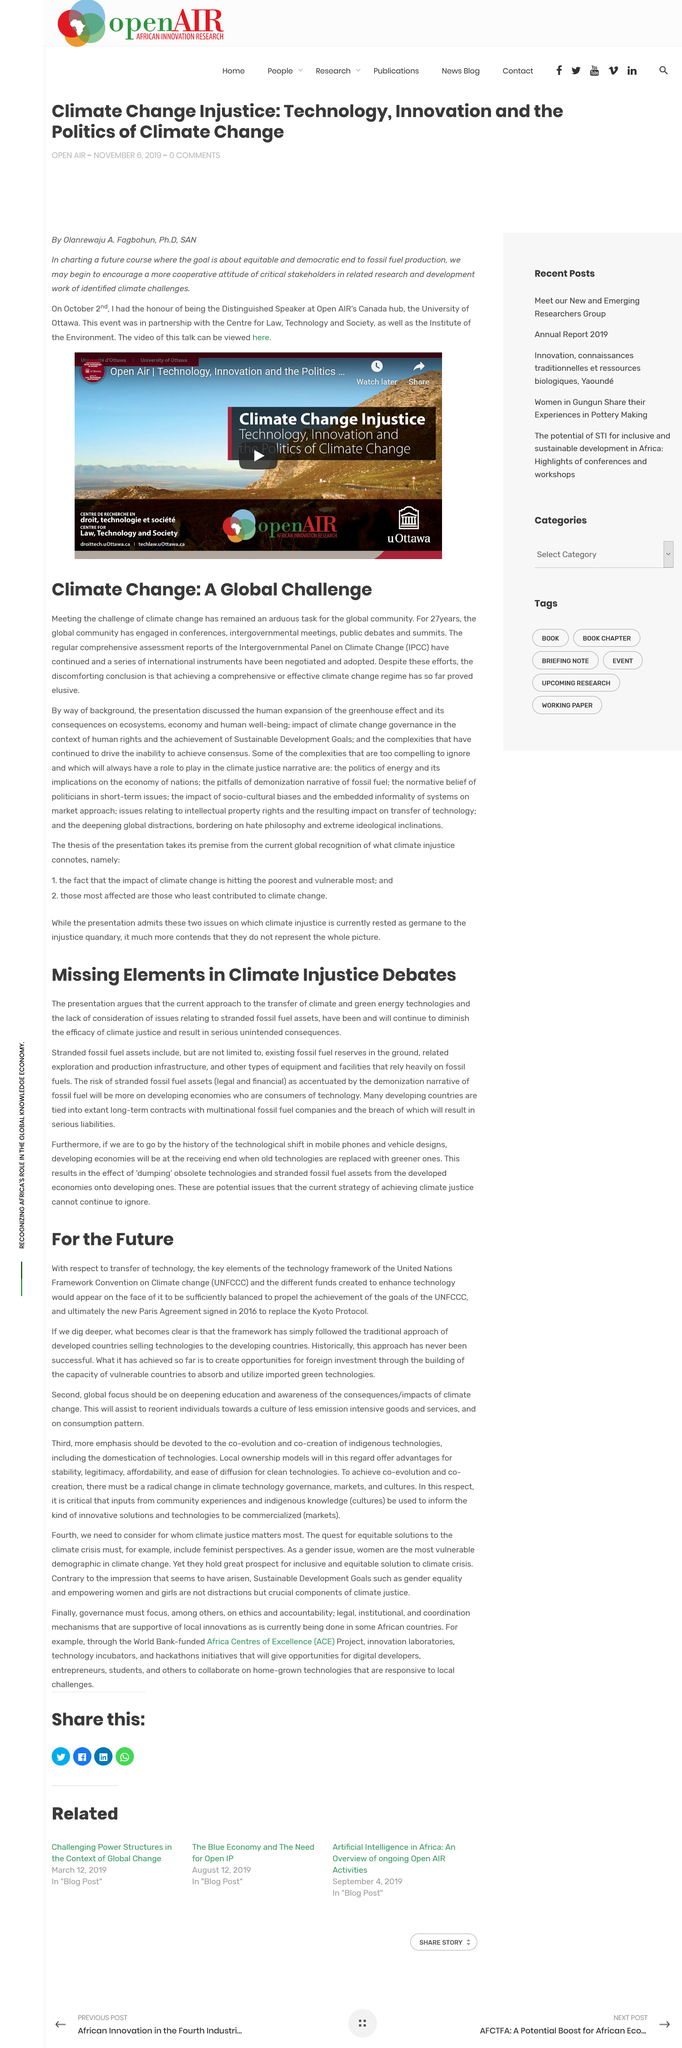Indicate a few pertinent items in this graphic. The Paris Agreement was signed and replaced the Kyoto Protocol in 2016, which was effective in 2005. Stranded fossil fuels, including existing fossil fuel reserves in the ground, related exploration and production infrastructure, and other equipment and facilities that rely heavily on fossil fuels, are a type of fossil fuel. The traditional approach of developed countries selling technologies to developing countries has not been successful in the past. The United Nations Framework Convention on Climate Change (UNFCCC) is an international agreement that aims to reduce greenhouse gas emissions and combat climate change. It was adopted in 1992 and has since been signed by nearly 200 countries. The UNFCCC sets out a framework for cooperative efforts to address the issue, including the development of emission reduction targets and the provision of financial and technical assistance to developing countries. Despite the transfer of climate and green energy, the lack of consideration for stranded fossil fuels continues to diminish the efficacy of climate justice. 